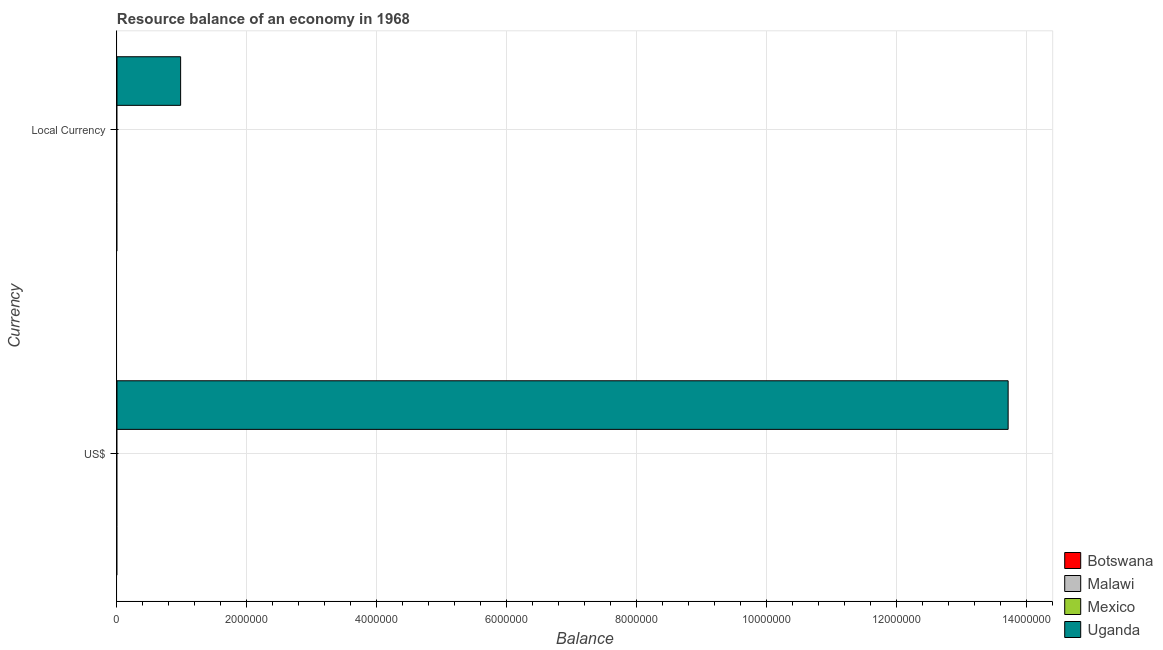How many different coloured bars are there?
Offer a very short reply. 1. How many bars are there on the 1st tick from the bottom?
Your response must be concise. 1. What is the label of the 1st group of bars from the top?
Provide a succinct answer. Local Currency. What is the resource balance in us$ in Uganda?
Make the answer very short. 1.37e+07. Across all countries, what is the maximum resource balance in constant us$?
Ensure brevity in your answer.  9.80e+05. Across all countries, what is the minimum resource balance in constant us$?
Ensure brevity in your answer.  0. In which country was the resource balance in constant us$ maximum?
Your answer should be very brief. Uganda. What is the total resource balance in constant us$ in the graph?
Keep it short and to the point. 9.80e+05. What is the difference between the resource balance in us$ in Malawi and the resource balance in constant us$ in Botswana?
Your response must be concise. 0. What is the average resource balance in us$ per country?
Keep it short and to the point. 3.43e+06. What is the difference between the resource balance in constant us$ and resource balance in us$ in Uganda?
Offer a very short reply. -1.27e+07. In how many countries, is the resource balance in us$ greater than 10800000 units?
Your answer should be very brief. 1. In how many countries, is the resource balance in us$ greater than the average resource balance in us$ taken over all countries?
Keep it short and to the point. 1. How many bars are there?
Ensure brevity in your answer.  2. How many countries are there in the graph?
Make the answer very short. 4. What is the difference between two consecutive major ticks on the X-axis?
Keep it short and to the point. 2.00e+06. Where does the legend appear in the graph?
Make the answer very short. Bottom right. How many legend labels are there?
Ensure brevity in your answer.  4. How are the legend labels stacked?
Make the answer very short. Vertical. What is the title of the graph?
Your answer should be compact. Resource balance of an economy in 1968. Does "St. Kitts and Nevis" appear as one of the legend labels in the graph?
Offer a very short reply. No. What is the label or title of the X-axis?
Your answer should be very brief. Balance. What is the label or title of the Y-axis?
Keep it short and to the point. Currency. What is the Balance of Botswana in US$?
Your answer should be compact. 0. What is the Balance in Uganda in US$?
Give a very brief answer. 1.37e+07. What is the Balance in Botswana in Local Currency?
Provide a succinct answer. 0. What is the Balance in Malawi in Local Currency?
Your response must be concise. 0. What is the Balance of Uganda in Local Currency?
Ensure brevity in your answer.  9.80e+05. Across all Currency, what is the maximum Balance of Uganda?
Make the answer very short. 1.37e+07. Across all Currency, what is the minimum Balance of Uganda?
Your answer should be compact. 9.80e+05. What is the total Balance of Botswana in the graph?
Offer a terse response. 0. What is the total Balance in Malawi in the graph?
Your answer should be compact. 0. What is the total Balance in Uganda in the graph?
Provide a succinct answer. 1.47e+07. What is the difference between the Balance of Uganda in US$ and that in Local Currency?
Provide a succinct answer. 1.27e+07. What is the average Balance of Mexico per Currency?
Provide a succinct answer. 0. What is the average Balance of Uganda per Currency?
Offer a very short reply. 7.35e+06. What is the ratio of the Balance of Uganda in US$ to that in Local Currency?
Your answer should be compact. 14. What is the difference between the highest and the second highest Balance in Uganda?
Keep it short and to the point. 1.27e+07. What is the difference between the highest and the lowest Balance of Uganda?
Give a very brief answer. 1.27e+07. 